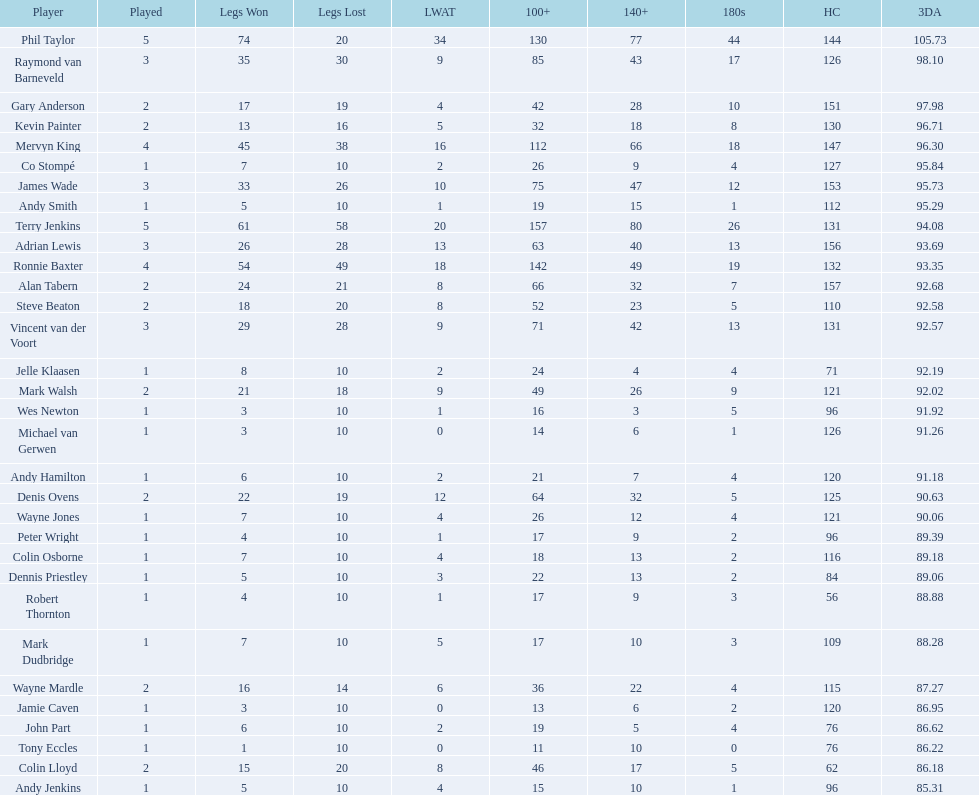Which player has his high checkout as 116? Colin Osborne. 